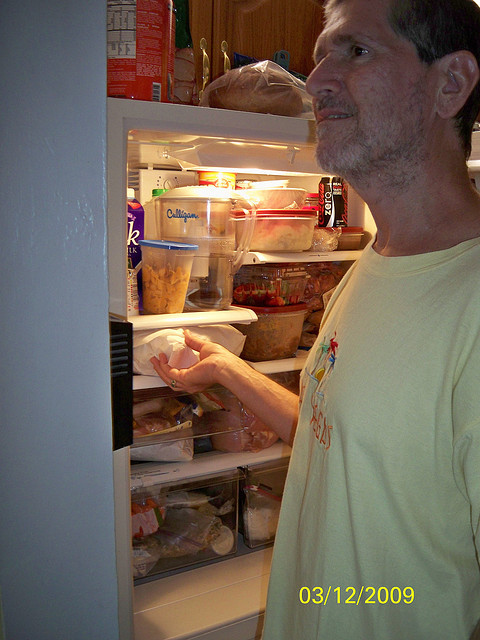Identify and read out the text in this image. Calligan ZERO 03 12 2009 LK k 